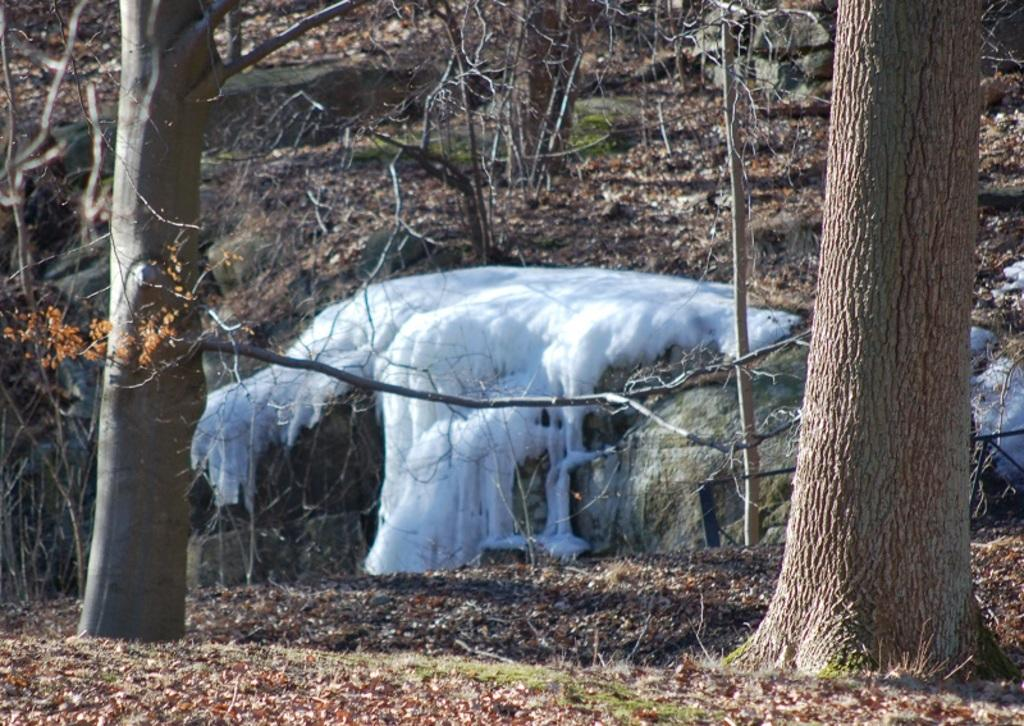What objects are located on both sides of the image? There are trunks on both sides of the image. What type of weather condition is depicted in the center of the image? It appears to be snow in the center of the image. What type of vegetation can be seen at the bottom side of the image? Dry leaves are present at the bottom side of the image. What type of vegetation can be seen in the background of the image? Dry plants are visible in the background of the image. What type of cream can be seen on the seashore in the image? There is no seashore or cream present in the image. 